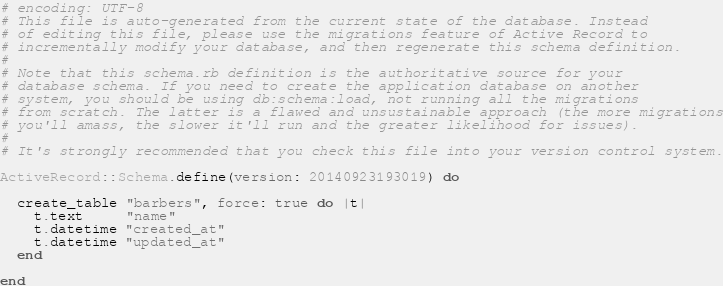Convert code to text. <code><loc_0><loc_0><loc_500><loc_500><_Ruby_># encoding: UTF-8
# This file is auto-generated from the current state of the database. Instead
# of editing this file, please use the migrations feature of Active Record to
# incrementally modify your database, and then regenerate this schema definition.
#
# Note that this schema.rb definition is the authoritative source for your
# database schema. If you need to create the application database on another
# system, you should be using db:schema:load, not running all the migrations
# from scratch. The latter is a flawed and unsustainable approach (the more migrations
# you'll amass, the slower it'll run and the greater likelihood for issues).
#
# It's strongly recommended that you check this file into your version control system.

ActiveRecord::Schema.define(version: 20140923193019) do

  create_table "barbers", force: true do |t|
    t.text     "name"
    t.datetime "created_at"
    t.datetime "updated_at"
  end

end
</code> 